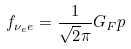Convert formula to latex. <formula><loc_0><loc_0><loc_500><loc_500>f _ { { \nu _ { e } } e } = \frac { 1 } { \sqrt { 2 } \pi } G _ { F } p</formula> 